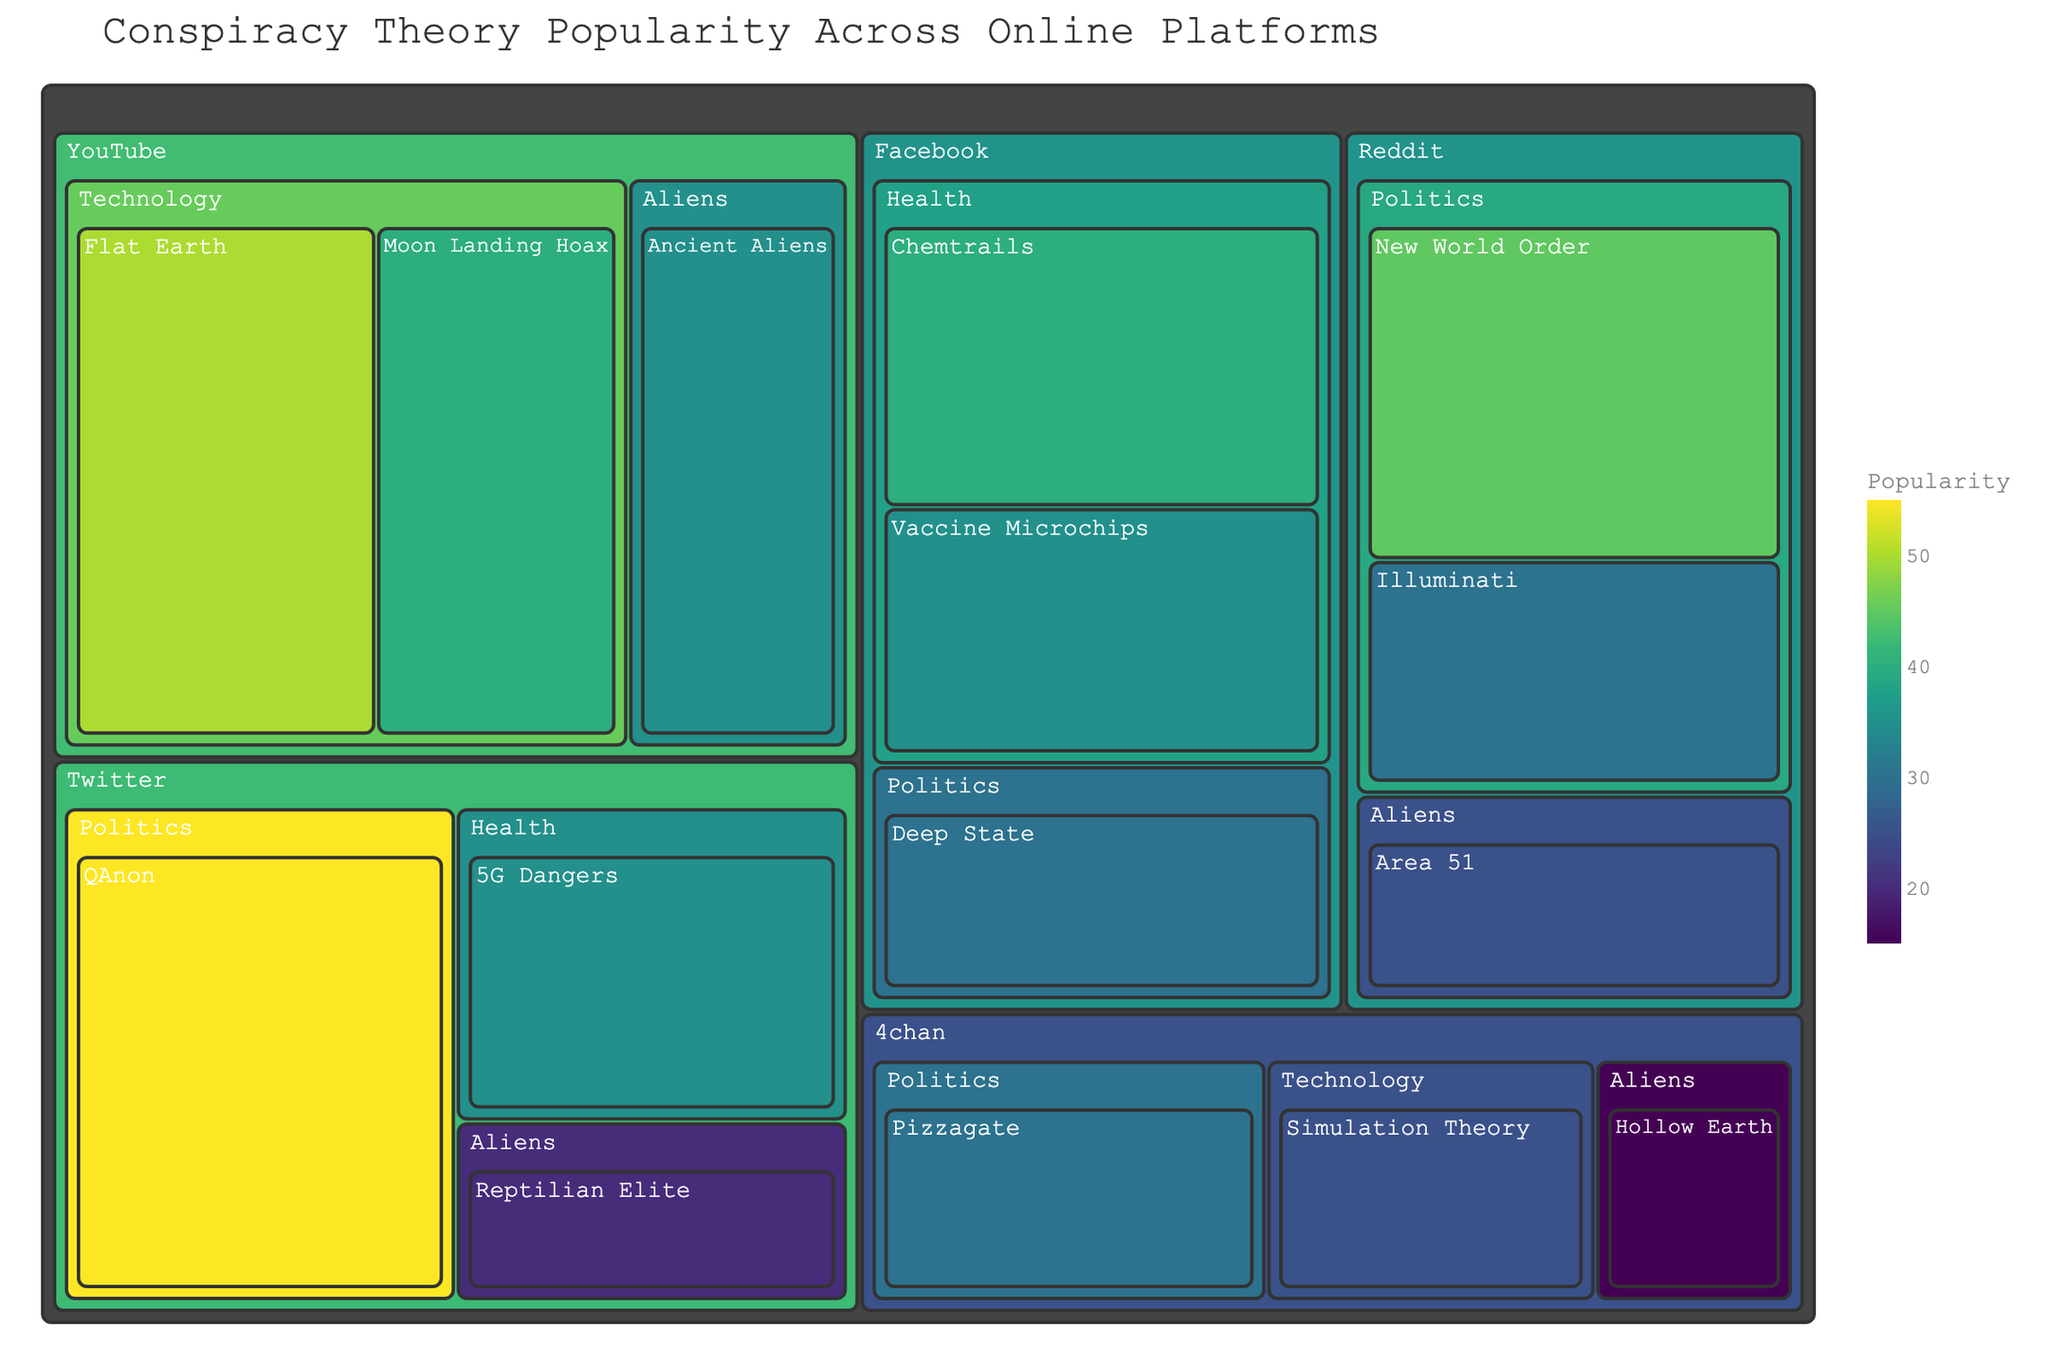What is the most popular conspiracy theory on Twitter? First, locate Twitter in the treemap. Under the Twitter section, identify the theory with the highest popularity value. The highest value for Twitter is for QAnon with a popularity of 55.
Answer: QAnon Which platform has the theory with the highest popularity overall? To find the platform with the highest popularity, examine all highest popularity values within each platform section. The highest value in the entire treemap is for Twitter's QAnon with a popularity of 55.
Answer: Twitter What is the total popularity of all the theories in the Health category? Within the Health category, identify and sum the popularity values. For Facebook: Chemtrails (40) and Vaccine Microchips (35). For Twitter: 5G Dangers (35). Summing these values: 40 + 35 + 35 = 110.
Answer: 110 Which theory is the second most popular on YouTube? Within the YouTube section, identify the theories and their popularity. The highest is Flat Earth (50), and the second highest is Moon Landing Hoax with a value of 40.
Answer: Moon Landing Hoax How does the popularity of Area 51 on Reddit compare to Reptilian Elite on Twitter? Locate both theories on their respective platforms. Area 51 on Reddit has a popularity of 25, and Reptilian Elite on Twitter has a popularity of 20. Compare these values: 25 (Area 51) is greater than 20 (Reptilian Elite).
Answer: Area 51 is more popular Which platform has the most categories listed? Examine the highest hierarchy level for each platform section and count the number of unique categories. Reddit, Facebook, and YouTube each have three categories, whereas Twitter and 4chan have fewer.
Answer: Reddit, Facebook, YouTube What is the average popularity of conspiracy theories on 4chan? In the 4chan section, sum and then divide the popularity values by the number of theories. The values are Pizzagate (30), Simulation Theory (25), Hollow Earth (15). (30 + 25 + 15) / 3 = 70 / 3 ≈ 23.33.
Answer: 23.33 Which theory in the Aliens category has the highest popularity? Look within the Aliens category across all platforms. Identify the highest values: Area 51 (25 on Reddit), Ancient Aliens (35 on YouTube), Reptilian Elite (20 on Twitter), Hollow Earth (15 on 4chan). The highest is Ancient Aliens on YouTube with a popularity of 35.
Answer: Ancient Aliens What is the combined popularity of the Illuminati and Deep State theories? Locate and add the popularity values for these theories. Illuminati (30 on Reddit) and Deep State (30 on Facebook). The combined popularity is 30 + 30 = 60.
Answer: 60 